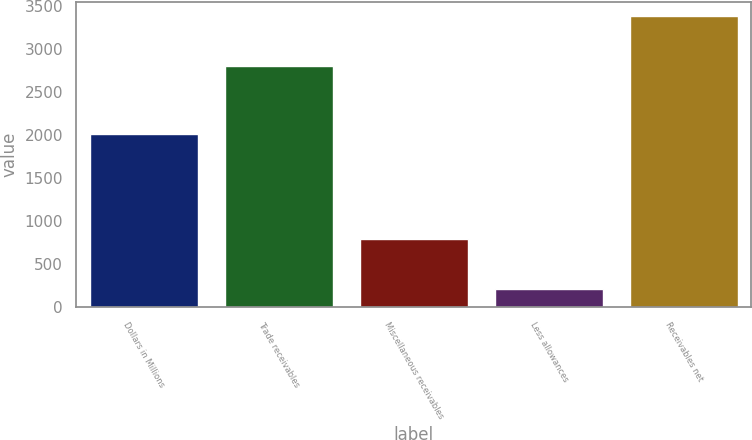Convert chart to OTSL. <chart><loc_0><loc_0><loc_500><loc_500><bar_chart><fcel>Dollars in Millions<fcel>Trade receivables<fcel>Miscellaneous receivables<fcel>Less allowances<fcel>Receivables net<nl><fcel>2005<fcel>2797<fcel>788<fcel>207<fcel>3378<nl></chart> 